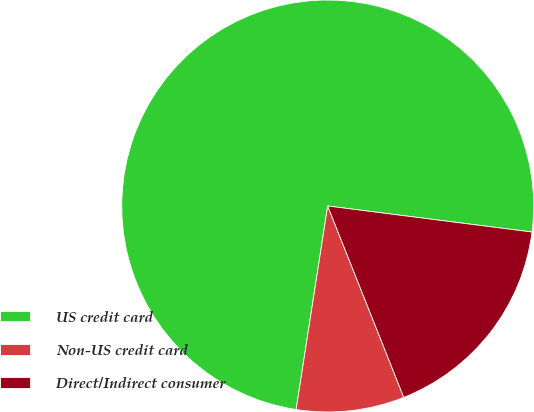Convert chart to OTSL. <chart><loc_0><loc_0><loc_500><loc_500><pie_chart><fcel>US credit card<fcel>Non-US credit card<fcel>Direct/Indirect consumer<nl><fcel>74.57%<fcel>8.47%<fcel>16.96%<nl></chart> 